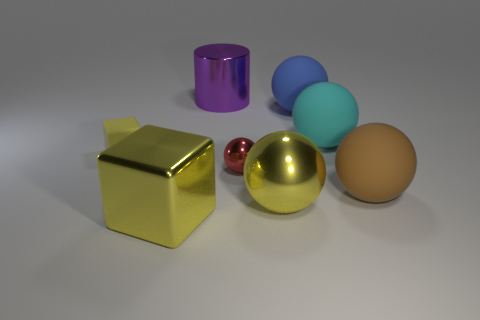Add 2 large objects. How many objects exist? 10 Subtract 3 balls. How many balls are left? 2 Subtract all yellow metallic spheres. How many spheres are left? 4 Subtract all balls. How many objects are left? 3 Subtract all blue spheres. How many blue cylinders are left? 0 Subtract all cubes. Subtract all large purple metal objects. How many objects are left? 5 Add 3 purple metallic objects. How many purple metallic objects are left? 4 Add 1 rubber objects. How many rubber objects exist? 5 Subtract all blue balls. How many balls are left? 4 Subtract 0 blue cubes. How many objects are left? 8 